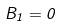<formula> <loc_0><loc_0><loc_500><loc_500>B _ { 1 } = 0</formula> 